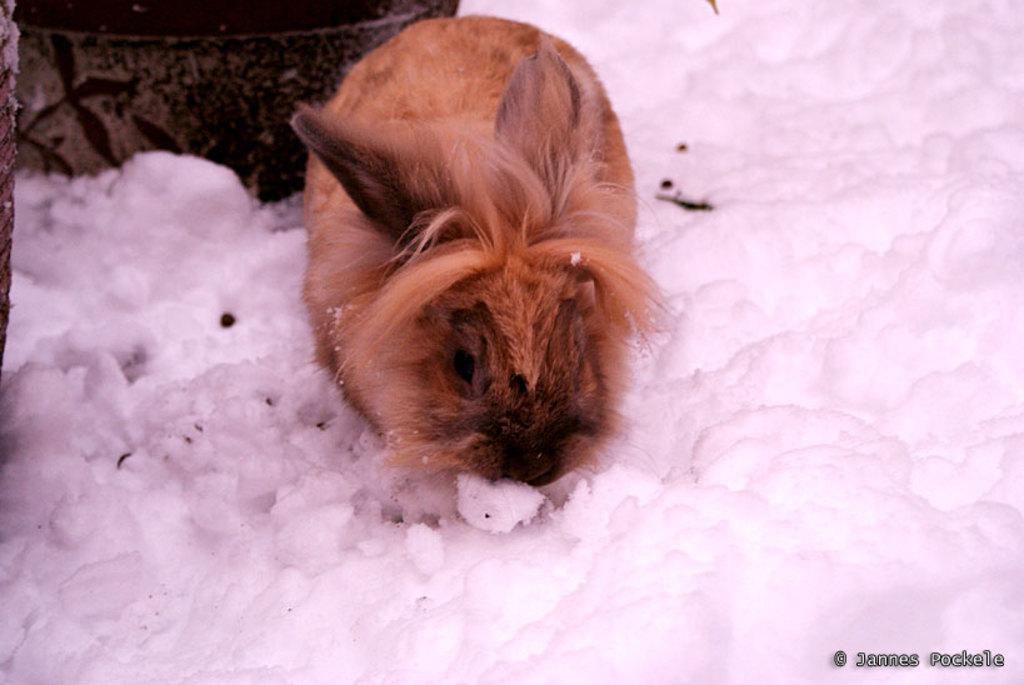What is the main subject of the image? There is a rabbit in the center of the image. Can you describe the environment in the image? There is snow around the area of the image. What type of lamp is hanging above the rabbit in the image? There is no lamp present in the image; it only features a rabbit in a snowy area. 